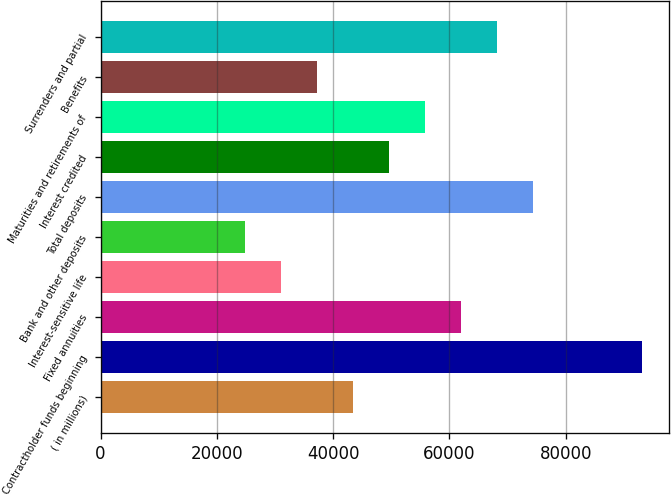Convert chart. <chart><loc_0><loc_0><loc_500><loc_500><bar_chart><fcel>( in millions)<fcel>Contractholder funds beginning<fcel>Fixed annuities<fcel>Interest-sensitive life<fcel>Bank and other deposits<fcel>Total deposits<fcel>Interest credited<fcel>Maturities and retirements of<fcel>Benefits<fcel>Surrenders and partial<nl><fcel>43425.6<fcel>93040<fcel>62031<fcel>31022<fcel>24820.2<fcel>74434.6<fcel>49627.4<fcel>55829.2<fcel>37223.8<fcel>68232.8<nl></chart> 